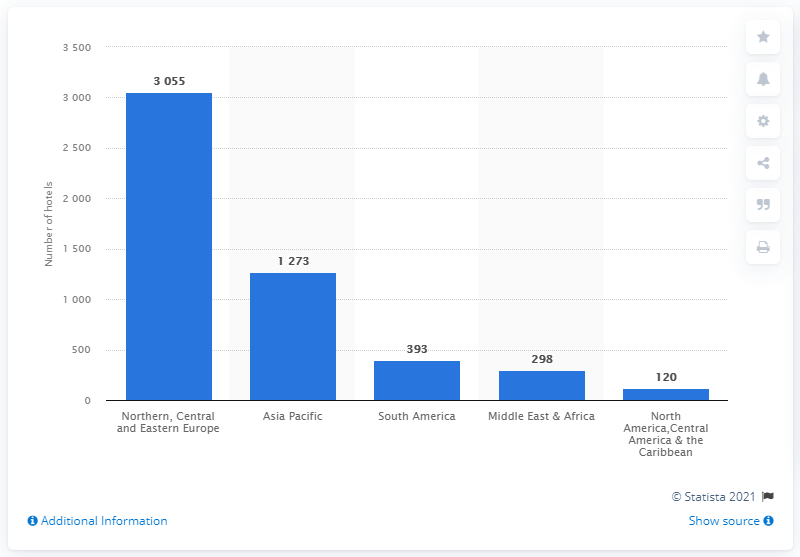Identify some key points in this picture. In 2020, Accor Group had a total of 298 hotels in the Middle East and Africa. 